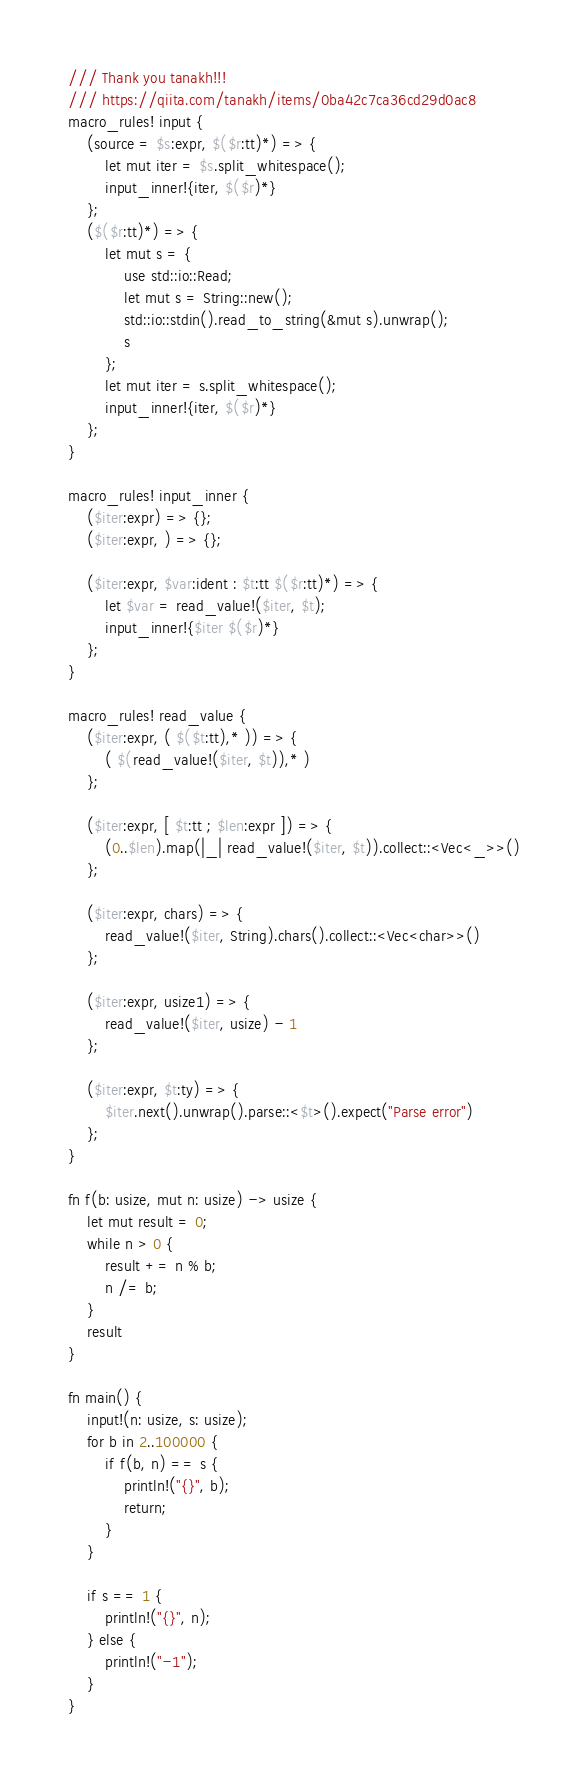Convert code to text. <code><loc_0><loc_0><loc_500><loc_500><_Rust_>/// Thank you tanakh!!!
/// https://qiita.com/tanakh/items/0ba42c7ca36cd29d0ac8
macro_rules! input {
    (source = $s:expr, $($r:tt)*) => {
        let mut iter = $s.split_whitespace();
        input_inner!{iter, $($r)*}
    };
    ($($r:tt)*) => {
        let mut s = {
            use std::io::Read;
            let mut s = String::new();
            std::io::stdin().read_to_string(&mut s).unwrap();
            s
        };
        let mut iter = s.split_whitespace();
        input_inner!{iter, $($r)*}
    };
}

macro_rules! input_inner {
    ($iter:expr) => {};
    ($iter:expr, ) => {};

    ($iter:expr, $var:ident : $t:tt $($r:tt)*) => {
        let $var = read_value!($iter, $t);
        input_inner!{$iter $($r)*}
    };
}

macro_rules! read_value {
    ($iter:expr, ( $($t:tt),* )) => {
        ( $(read_value!($iter, $t)),* )
    };

    ($iter:expr, [ $t:tt ; $len:expr ]) => {
        (0..$len).map(|_| read_value!($iter, $t)).collect::<Vec<_>>()
    };

    ($iter:expr, chars) => {
        read_value!($iter, String).chars().collect::<Vec<char>>()
    };

    ($iter:expr, usize1) => {
        read_value!($iter, usize) - 1
    };

    ($iter:expr, $t:ty) => {
        $iter.next().unwrap().parse::<$t>().expect("Parse error")
    };
}

fn f(b: usize, mut n: usize) -> usize {
    let mut result = 0;
    while n > 0 {
        result += n % b;
        n /= b;
    }
    result
}

fn main() {
    input!(n: usize, s: usize);
    for b in 2..100000 {
        if f(b, n) == s {
            println!("{}", b);
            return;
        }
    }

    if s == 1 {
        println!("{}", n);
    } else {
        println!("-1");
    }
}
</code> 